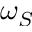Convert formula to latex. <formula><loc_0><loc_0><loc_500><loc_500>\omega _ { S }</formula> 